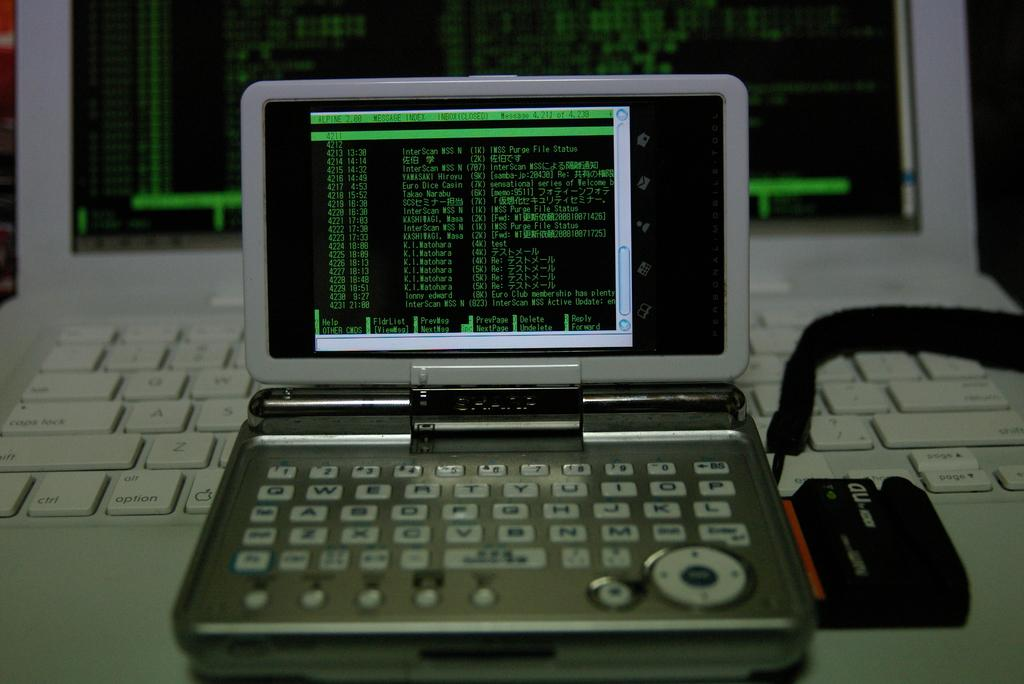<image>
Render a clear and concise summary of the photo. A small gray device pulgged into a white laptop with the little screen displaying the big screen and a device with a logo of nb on the side 